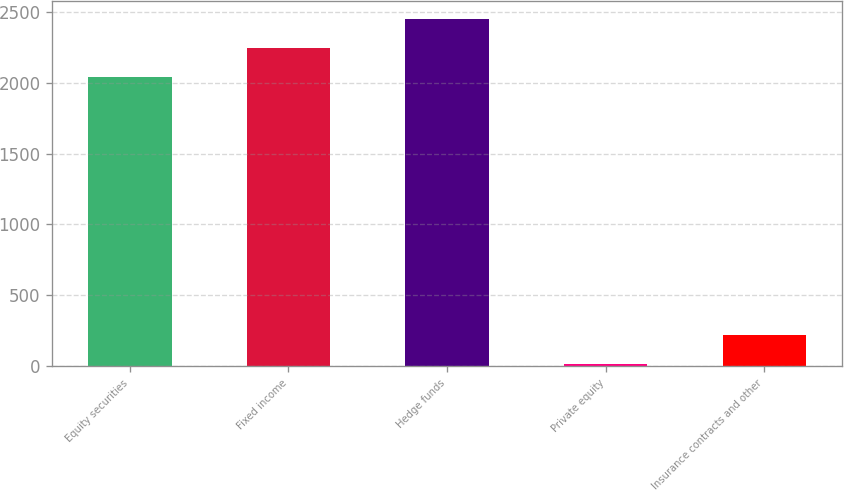Convert chart to OTSL. <chart><loc_0><loc_0><loc_500><loc_500><bar_chart><fcel>Equity securities<fcel>Fixed income<fcel>Hedge funds<fcel>Private equity<fcel>Insurance contracts and other<nl><fcel>2040<fcel>2244.5<fcel>2449<fcel>15<fcel>219.5<nl></chart> 